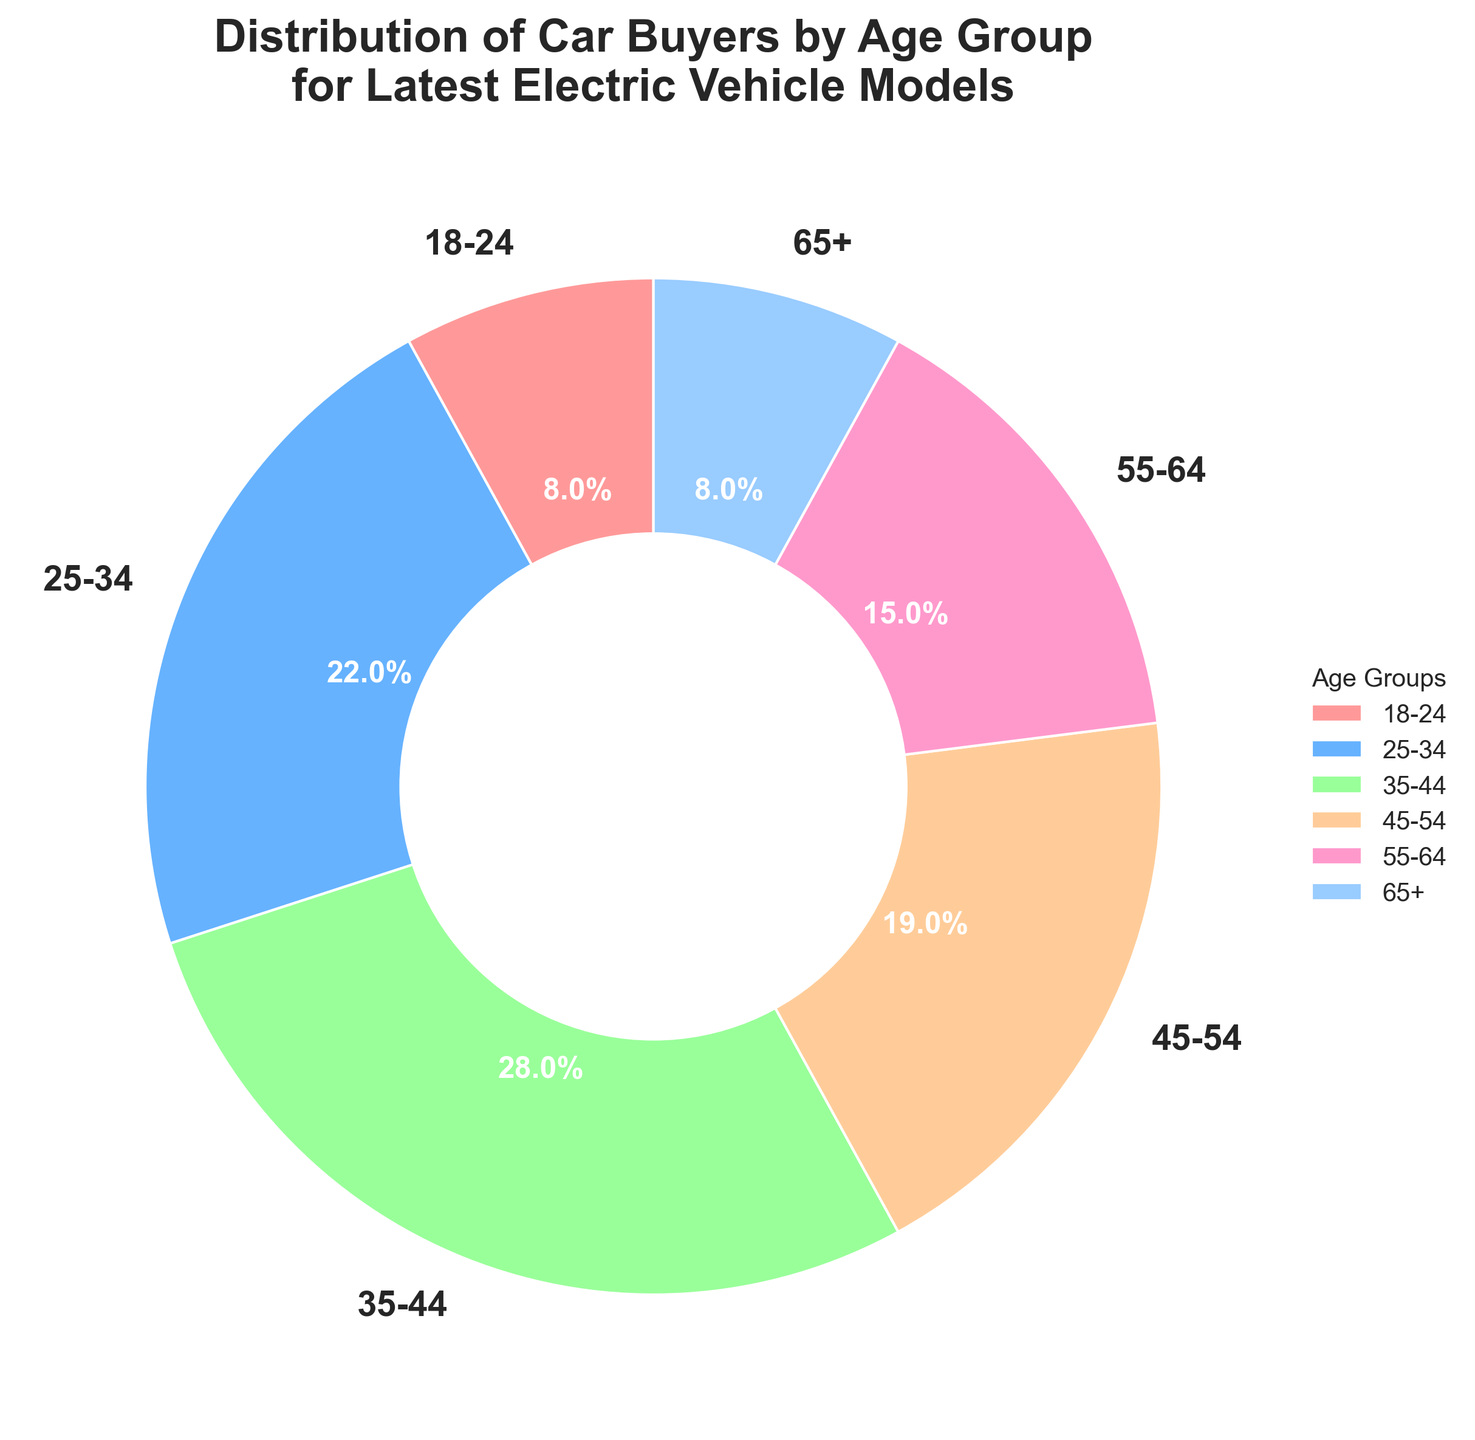What age group has the largest percentage of car buyers for the latest electric vehicle models? By looking at the pie chart, we can see that the age group 35-44 has the largest segment which represents the highest percentage.
Answer: 35-44 Which age groups have equal percentages of car buyers? The pie chart shows that the age groups 18-24 and 65+ have segments of the same size, each representing 8% of car buyers.
Answer: 18-24 and 65+ How much more percentage of car buyers do the 35-44 age group have compared to the 25-34 age group? The 35-44 age group has 28%, while the 25-34 age group has 22%. The difference is calculated as 28% - 22% = 6%.
Answer: 6% Which age group has the smallest percentage of car buyers and what is it? By visually inspecting the pie chart, we can identify that both the 18-24 and 65+ age groups have the smallest segments, each representing 8%.
Answer: 18-24 and 65+, 8% What is the combined percentage of car buyers for the age groups between 25 and 54 years old? The percentages for the age groups 25-34, 35-44, and 45-54 are 22%, 28%, and 19%, respectively. Adding them together gives 22% + 28% + 19% = 69%.
Answer: 69% Which age group has more car buyers, 45-54 or 55-64? By comparing the segments on the pie chart, the age group 45-54 with 19% has more car buyers than the 55-64 age group which has 15%.
Answer: 45-54 If the total number of car buyers is 1000, how many buyers are aged 45-54? The 45-54 age group represents 19% of the total car buyers. Therefore, 19% of 1000 is calculated as 1000 * 0.19 = 190.
Answer: 190 What visual attribute can be used to quickly identify the age group with the highest percentage of car buyers? The largest segment in the pie chart visually stands out, which corresponds to the highest percentage.
Answer: Largest segment How does the percentage of buyers aged 55-64 compare to the percentage of buyers aged 18-24? The pie chart segments show the 55-64 age group has 15%, while the 18-24 age group has 8%. 15% is greater than 8%.
Answer: 55-64 > 18-24 What is the total percentage of car buyers for age groups below 35 years old? The groups below 35 are 18-24 and 25-34. Their percentages are 8% and 22%, respectively. Adding them together gives 8% + 22% = 30%.
Answer: 30% 